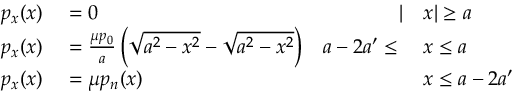Convert formula to latex. <formula><loc_0><loc_0><loc_500><loc_500>\begin{array} { r l r l } { p _ { x } ( x ) } & = 0 } & { | } & x | \geq a } \\ { p _ { x } ( x ) } & = { \frac { \mu p _ { 0 } } { a } } \left ( { \sqrt { a ^ { 2 } - x ^ { 2 } } } - { \sqrt { a ^ { 2 } - x ^ { 2 } } } \right ) } & { a - 2 a ^ { \prime } } & x \leq a } \\ { p _ { x } ( x ) } & = \mu p _ { n } ( x ) } & x \leq a - 2 a ^ { \prime } } \end{array}</formula> 